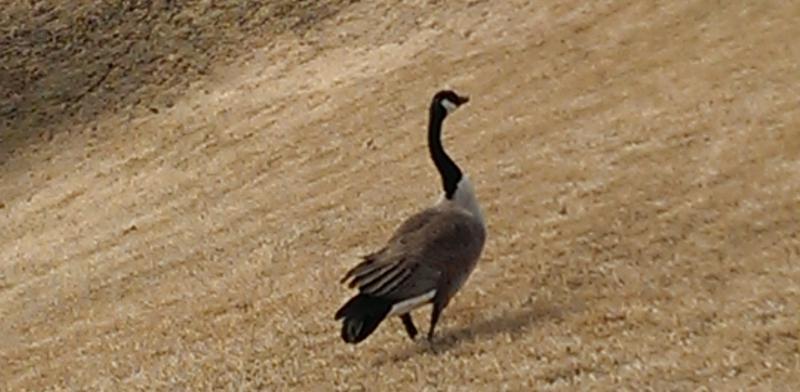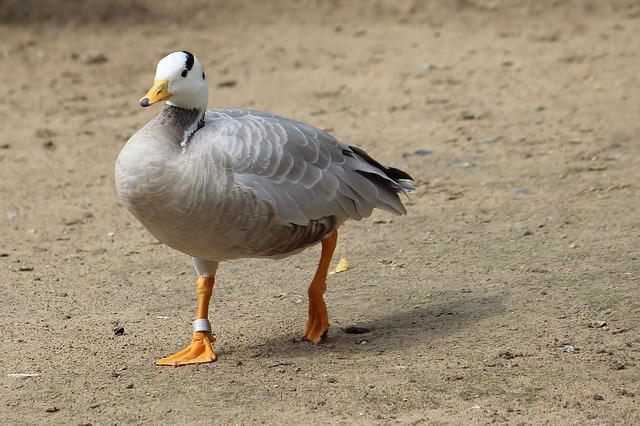The first image is the image on the left, the second image is the image on the right. For the images shown, is this caption "There are two birds in the picture on the right." true? Answer yes or no. No. 